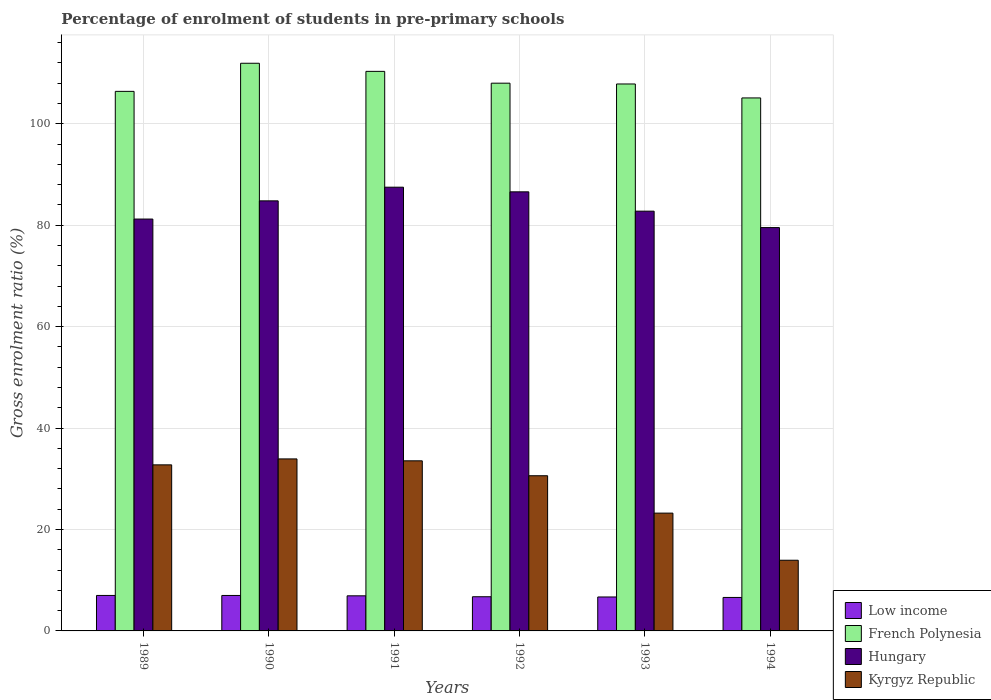How many different coloured bars are there?
Ensure brevity in your answer.  4. Are the number of bars per tick equal to the number of legend labels?
Keep it short and to the point. Yes. How many bars are there on the 6th tick from the right?
Offer a terse response. 4. In how many cases, is the number of bars for a given year not equal to the number of legend labels?
Your answer should be compact. 0. What is the percentage of students enrolled in pre-primary schools in Low income in 1994?
Provide a succinct answer. 6.6. Across all years, what is the maximum percentage of students enrolled in pre-primary schools in Low income?
Your response must be concise. 6.99. Across all years, what is the minimum percentage of students enrolled in pre-primary schools in Hungary?
Give a very brief answer. 79.53. What is the total percentage of students enrolled in pre-primary schools in French Polynesia in the graph?
Your response must be concise. 649.58. What is the difference between the percentage of students enrolled in pre-primary schools in Kyrgyz Republic in 1992 and that in 1994?
Provide a short and direct response. 16.66. What is the difference between the percentage of students enrolled in pre-primary schools in Low income in 1993 and the percentage of students enrolled in pre-primary schools in French Polynesia in 1990?
Your response must be concise. -105.23. What is the average percentage of students enrolled in pre-primary schools in Hungary per year?
Ensure brevity in your answer.  83.73. In the year 1994, what is the difference between the percentage of students enrolled in pre-primary schools in French Polynesia and percentage of students enrolled in pre-primary schools in Kyrgyz Republic?
Provide a short and direct response. 91.16. What is the ratio of the percentage of students enrolled in pre-primary schools in Hungary in 1989 to that in 1993?
Your answer should be compact. 0.98. Is the percentage of students enrolled in pre-primary schools in French Polynesia in 1989 less than that in 1990?
Provide a succinct answer. Yes. What is the difference between the highest and the second highest percentage of students enrolled in pre-primary schools in Kyrgyz Republic?
Give a very brief answer. 0.38. What is the difference between the highest and the lowest percentage of students enrolled in pre-primary schools in Kyrgyz Republic?
Offer a very short reply. 19.98. In how many years, is the percentage of students enrolled in pre-primary schools in Low income greater than the average percentage of students enrolled in pre-primary schools in Low income taken over all years?
Provide a succinct answer. 3. What does the 2nd bar from the left in 1990 represents?
Your response must be concise. French Polynesia. What does the 2nd bar from the right in 1993 represents?
Ensure brevity in your answer.  Hungary. Is it the case that in every year, the sum of the percentage of students enrolled in pre-primary schools in French Polynesia and percentage of students enrolled in pre-primary schools in Hungary is greater than the percentage of students enrolled in pre-primary schools in Low income?
Make the answer very short. Yes. How many years are there in the graph?
Offer a terse response. 6. Does the graph contain grids?
Your answer should be very brief. Yes. How are the legend labels stacked?
Your answer should be compact. Vertical. What is the title of the graph?
Give a very brief answer. Percentage of enrolment of students in pre-primary schools. Does "Micronesia" appear as one of the legend labels in the graph?
Offer a terse response. No. What is the Gross enrolment ratio (%) in Low income in 1989?
Give a very brief answer. 6.99. What is the Gross enrolment ratio (%) of French Polynesia in 1989?
Ensure brevity in your answer.  106.39. What is the Gross enrolment ratio (%) in Hungary in 1989?
Keep it short and to the point. 81.21. What is the Gross enrolment ratio (%) in Kyrgyz Republic in 1989?
Offer a terse response. 32.74. What is the Gross enrolment ratio (%) in Low income in 1990?
Provide a short and direct response. 6.99. What is the Gross enrolment ratio (%) in French Polynesia in 1990?
Provide a succinct answer. 111.93. What is the Gross enrolment ratio (%) of Hungary in 1990?
Provide a succinct answer. 84.8. What is the Gross enrolment ratio (%) in Kyrgyz Republic in 1990?
Offer a very short reply. 33.92. What is the Gross enrolment ratio (%) in Low income in 1991?
Ensure brevity in your answer.  6.92. What is the Gross enrolment ratio (%) in French Polynesia in 1991?
Offer a terse response. 110.33. What is the Gross enrolment ratio (%) in Hungary in 1991?
Your answer should be very brief. 87.49. What is the Gross enrolment ratio (%) in Kyrgyz Republic in 1991?
Make the answer very short. 33.54. What is the Gross enrolment ratio (%) of Low income in 1992?
Ensure brevity in your answer.  6.74. What is the Gross enrolment ratio (%) of French Polynesia in 1992?
Offer a terse response. 108. What is the Gross enrolment ratio (%) of Hungary in 1992?
Ensure brevity in your answer.  86.58. What is the Gross enrolment ratio (%) of Kyrgyz Republic in 1992?
Give a very brief answer. 30.6. What is the Gross enrolment ratio (%) in Low income in 1993?
Your answer should be very brief. 6.69. What is the Gross enrolment ratio (%) in French Polynesia in 1993?
Ensure brevity in your answer.  107.84. What is the Gross enrolment ratio (%) in Hungary in 1993?
Keep it short and to the point. 82.77. What is the Gross enrolment ratio (%) of Kyrgyz Republic in 1993?
Give a very brief answer. 23.23. What is the Gross enrolment ratio (%) of Low income in 1994?
Your response must be concise. 6.6. What is the Gross enrolment ratio (%) of French Polynesia in 1994?
Your answer should be compact. 105.09. What is the Gross enrolment ratio (%) in Hungary in 1994?
Provide a succinct answer. 79.53. What is the Gross enrolment ratio (%) in Kyrgyz Republic in 1994?
Ensure brevity in your answer.  13.94. Across all years, what is the maximum Gross enrolment ratio (%) in Low income?
Give a very brief answer. 6.99. Across all years, what is the maximum Gross enrolment ratio (%) of French Polynesia?
Your answer should be compact. 111.93. Across all years, what is the maximum Gross enrolment ratio (%) of Hungary?
Offer a very short reply. 87.49. Across all years, what is the maximum Gross enrolment ratio (%) of Kyrgyz Republic?
Ensure brevity in your answer.  33.92. Across all years, what is the minimum Gross enrolment ratio (%) in Low income?
Keep it short and to the point. 6.6. Across all years, what is the minimum Gross enrolment ratio (%) in French Polynesia?
Provide a short and direct response. 105.09. Across all years, what is the minimum Gross enrolment ratio (%) of Hungary?
Your answer should be compact. 79.53. Across all years, what is the minimum Gross enrolment ratio (%) of Kyrgyz Republic?
Keep it short and to the point. 13.94. What is the total Gross enrolment ratio (%) of Low income in the graph?
Your answer should be very brief. 40.94. What is the total Gross enrolment ratio (%) of French Polynesia in the graph?
Offer a terse response. 649.58. What is the total Gross enrolment ratio (%) of Hungary in the graph?
Keep it short and to the point. 502.37. What is the total Gross enrolment ratio (%) of Kyrgyz Republic in the graph?
Ensure brevity in your answer.  167.96. What is the difference between the Gross enrolment ratio (%) in Low income in 1989 and that in 1990?
Provide a succinct answer. 0. What is the difference between the Gross enrolment ratio (%) in French Polynesia in 1989 and that in 1990?
Your answer should be very brief. -5.54. What is the difference between the Gross enrolment ratio (%) of Hungary in 1989 and that in 1990?
Give a very brief answer. -3.59. What is the difference between the Gross enrolment ratio (%) in Kyrgyz Republic in 1989 and that in 1990?
Give a very brief answer. -1.17. What is the difference between the Gross enrolment ratio (%) in Low income in 1989 and that in 1991?
Offer a terse response. 0.07. What is the difference between the Gross enrolment ratio (%) in French Polynesia in 1989 and that in 1991?
Make the answer very short. -3.94. What is the difference between the Gross enrolment ratio (%) in Hungary in 1989 and that in 1991?
Give a very brief answer. -6.28. What is the difference between the Gross enrolment ratio (%) of Kyrgyz Republic in 1989 and that in 1991?
Your answer should be compact. -0.8. What is the difference between the Gross enrolment ratio (%) of Low income in 1989 and that in 1992?
Keep it short and to the point. 0.26. What is the difference between the Gross enrolment ratio (%) in French Polynesia in 1989 and that in 1992?
Ensure brevity in your answer.  -1.61. What is the difference between the Gross enrolment ratio (%) of Hungary in 1989 and that in 1992?
Offer a very short reply. -5.37. What is the difference between the Gross enrolment ratio (%) in Kyrgyz Republic in 1989 and that in 1992?
Provide a short and direct response. 2.15. What is the difference between the Gross enrolment ratio (%) in Low income in 1989 and that in 1993?
Give a very brief answer. 0.3. What is the difference between the Gross enrolment ratio (%) of French Polynesia in 1989 and that in 1993?
Provide a short and direct response. -1.46. What is the difference between the Gross enrolment ratio (%) of Hungary in 1989 and that in 1993?
Provide a succinct answer. -1.56. What is the difference between the Gross enrolment ratio (%) in Kyrgyz Republic in 1989 and that in 1993?
Your response must be concise. 9.52. What is the difference between the Gross enrolment ratio (%) of Low income in 1989 and that in 1994?
Ensure brevity in your answer.  0.4. What is the difference between the Gross enrolment ratio (%) in French Polynesia in 1989 and that in 1994?
Make the answer very short. 1.3. What is the difference between the Gross enrolment ratio (%) of Hungary in 1989 and that in 1994?
Provide a succinct answer. 1.68. What is the difference between the Gross enrolment ratio (%) of Kyrgyz Republic in 1989 and that in 1994?
Provide a short and direct response. 18.81. What is the difference between the Gross enrolment ratio (%) of Low income in 1990 and that in 1991?
Make the answer very short. 0.07. What is the difference between the Gross enrolment ratio (%) in French Polynesia in 1990 and that in 1991?
Your answer should be compact. 1.6. What is the difference between the Gross enrolment ratio (%) in Hungary in 1990 and that in 1991?
Ensure brevity in your answer.  -2.7. What is the difference between the Gross enrolment ratio (%) in Kyrgyz Republic in 1990 and that in 1991?
Offer a terse response. 0.38. What is the difference between the Gross enrolment ratio (%) of Low income in 1990 and that in 1992?
Give a very brief answer. 0.25. What is the difference between the Gross enrolment ratio (%) of French Polynesia in 1990 and that in 1992?
Provide a short and direct response. 3.93. What is the difference between the Gross enrolment ratio (%) in Hungary in 1990 and that in 1992?
Your response must be concise. -1.78. What is the difference between the Gross enrolment ratio (%) of Kyrgyz Republic in 1990 and that in 1992?
Provide a short and direct response. 3.32. What is the difference between the Gross enrolment ratio (%) of Low income in 1990 and that in 1993?
Keep it short and to the point. 0.3. What is the difference between the Gross enrolment ratio (%) in French Polynesia in 1990 and that in 1993?
Provide a short and direct response. 4.09. What is the difference between the Gross enrolment ratio (%) in Hungary in 1990 and that in 1993?
Keep it short and to the point. 2.03. What is the difference between the Gross enrolment ratio (%) of Kyrgyz Republic in 1990 and that in 1993?
Make the answer very short. 10.69. What is the difference between the Gross enrolment ratio (%) of Low income in 1990 and that in 1994?
Give a very brief answer. 0.39. What is the difference between the Gross enrolment ratio (%) of French Polynesia in 1990 and that in 1994?
Offer a terse response. 6.84. What is the difference between the Gross enrolment ratio (%) of Hungary in 1990 and that in 1994?
Your answer should be compact. 5.27. What is the difference between the Gross enrolment ratio (%) in Kyrgyz Republic in 1990 and that in 1994?
Your answer should be very brief. 19.98. What is the difference between the Gross enrolment ratio (%) in Low income in 1991 and that in 1992?
Ensure brevity in your answer.  0.18. What is the difference between the Gross enrolment ratio (%) of French Polynesia in 1991 and that in 1992?
Your answer should be very brief. 2.33. What is the difference between the Gross enrolment ratio (%) in Hungary in 1991 and that in 1992?
Make the answer very short. 0.92. What is the difference between the Gross enrolment ratio (%) of Kyrgyz Republic in 1991 and that in 1992?
Offer a very short reply. 2.94. What is the difference between the Gross enrolment ratio (%) of Low income in 1991 and that in 1993?
Provide a short and direct response. 0.23. What is the difference between the Gross enrolment ratio (%) of French Polynesia in 1991 and that in 1993?
Offer a very short reply. 2.49. What is the difference between the Gross enrolment ratio (%) in Hungary in 1991 and that in 1993?
Your answer should be compact. 4.73. What is the difference between the Gross enrolment ratio (%) of Kyrgyz Republic in 1991 and that in 1993?
Your response must be concise. 10.31. What is the difference between the Gross enrolment ratio (%) of Low income in 1991 and that in 1994?
Offer a very short reply. 0.32. What is the difference between the Gross enrolment ratio (%) in French Polynesia in 1991 and that in 1994?
Your answer should be very brief. 5.24. What is the difference between the Gross enrolment ratio (%) in Hungary in 1991 and that in 1994?
Your response must be concise. 7.96. What is the difference between the Gross enrolment ratio (%) of Kyrgyz Republic in 1991 and that in 1994?
Offer a very short reply. 19.6. What is the difference between the Gross enrolment ratio (%) in Low income in 1992 and that in 1993?
Provide a short and direct response. 0.04. What is the difference between the Gross enrolment ratio (%) of French Polynesia in 1992 and that in 1993?
Offer a terse response. 0.16. What is the difference between the Gross enrolment ratio (%) of Hungary in 1992 and that in 1993?
Your response must be concise. 3.81. What is the difference between the Gross enrolment ratio (%) of Kyrgyz Republic in 1992 and that in 1993?
Offer a terse response. 7.37. What is the difference between the Gross enrolment ratio (%) of Low income in 1992 and that in 1994?
Offer a terse response. 0.14. What is the difference between the Gross enrolment ratio (%) in French Polynesia in 1992 and that in 1994?
Make the answer very short. 2.91. What is the difference between the Gross enrolment ratio (%) in Hungary in 1992 and that in 1994?
Make the answer very short. 7.05. What is the difference between the Gross enrolment ratio (%) of Kyrgyz Republic in 1992 and that in 1994?
Your answer should be compact. 16.66. What is the difference between the Gross enrolment ratio (%) in Low income in 1993 and that in 1994?
Your answer should be very brief. 0.1. What is the difference between the Gross enrolment ratio (%) in French Polynesia in 1993 and that in 1994?
Give a very brief answer. 2.75. What is the difference between the Gross enrolment ratio (%) of Hungary in 1993 and that in 1994?
Offer a terse response. 3.24. What is the difference between the Gross enrolment ratio (%) of Kyrgyz Republic in 1993 and that in 1994?
Provide a short and direct response. 9.29. What is the difference between the Gross enrolment ratio (%) in Low income in 1989 and the Gross enrolment ratio (%) in French Polynesia in 1990?
Your response must be concise. -104.93. What is the difference between the Gross enrolment ratio (%) of Low income in 1989 and the Gross enrolment ratio (%) of Hungary in 1990?
Ensure brevity in your answer.  -77.8. What is the difference between the Gross enrolment ratio (%) in Low income in 1989 and the Gross enrolment ratio (%) in Kyrgyz Republic in 1990?
Your response must be concise. -26.92. What is the difference between the Gross enrolment ratio (%) of French Polynesia in 1989 and the Gross enrolment ratio (%) of Hungary in 1990?
Offer a terse response. 21.59. What is the difference between the Gross enrolment ratio (%) in French Polynesia in 1989 and the Gross enrolment ratio (%) in Kyrgyz Republic in 1990?
Ensure brevity in your answer.  72.47. What is the difference between the Gross enrolment ratio (%) in Hungary in 1989 and the Gross enrolment ratio (%) in Kyrgyz Republic in 1990?
Your answer should be compact. 47.29. What is the difference between the Gross enrolment ratio (%) in Low income in 1989 and the Gross enrolment ratio (%) in French Polynesia in 1991?
Keep it short and to the point. -103.34. What is the difference between the Gross enrolment ratio (%) in Low income in 1989 and the Gross enrolment ratio (%) in Hungary in 1991?
Provide a succinct answer. -80.5. What is the difference between the Gross enrolment ratio (%) of Low income in 1989 and the Gross enrolment ratio (%) of Kyrgyz Republic in 1991?
Your response must be concise. -26.55. What is the difference between the Gross enrolment ratio (%) in French Polynesia in 1989 and the Gross enrolment ratio (%) in Hungary in 1991?
Keep it short and to the point. 18.89. What is the difference between the Gross enrolment ratio (%) in French Polynesia in 1989 and the Gross enrolment ratio (%) in Kyrgyz Republic in 1991?
Your answer should be very brief. 72.85. What is the difference between the Gross enrolment ratio (%) of Hungary in 1989 and the Gross enrolment ratio (%) of Kyrgyz Republic in 1991?
Keep it short and to the point. 47.67. What is the difference between the Gross enrolment ratio (%) in Low income in 1989 and the Gross enrolment ratio (%) in French Polynesia in 1992?
Your answer should be very brief. -101.01. What is the difference between the Gross enrolment ratio (%) in Low income in 1989 and the Gross enrolment ratio (%) in Hungary in 1992?
Give a very brief answer. -79.58. What is the difference between the Gross enrolment ratio (%) in Low income in 1989 and the Gross enrolment ratio (%) in Kyrgyz Republic in 1992?
Your response must be concise. -23.6. What is the difference between the Gross enrolment ratio (%) of French Polynesia in 1989 and the Gross enrolment ratio (%) of Hungary in 1992?
Give a very brief answer. 19.81. What is the difference between the Gross enrolment ratio (%) in French Polynesia in 1989 and the Gross enrolment ratio (%) in Kyrgyz Republic in 1992?
Your answer should be very brief. 75.79. What is the difference between the Gross enrolment ratio (%) of Hungary in 1989 and the Gross enrolment ratio (%) of Kyrgyz Republic in 1992?
Ensure brevity in your answer.  50.61. What is the difference between the Gross enrolment ratio (%) of Low income in 1989 and the Gross enrolment ratio (%) of French Polynesia in 1993?
Give a very brief answer. -100.85. What is the difference between the Gross enrolment ratio (%) of Low income in 1989 and the Gross enrolment ratio (%) of Hungary in 1993?
Give a very brief answer. -75.77. What is the difference between the Gross enrolment ratio (%) in Low income in 1989 and the Gross enrolment ratio (%) in Kyrgyz Republic in 1993?
Your response must be concise. -16.23. What is the difference between the Gross enrolment ratio (%) in French Polynesia in 1989 and the Gross enrolment ratio (%) in Hungary in 1993?
Make the answer very short. 23.62. What is the difference between the Gross enrolment ratio (%) of French Polynesia in 1989 and the Gross enrolment ratio (%) of Kyrgyz Republic in 1993?
Your response must be concise. 83.16. What is the difference between the Gross enrolment ratio (%) of Hungary in 1989 and the Gross enrolment ratio (%) of Kyrgyz Republic in 1993?
Your answer should be compact. 57.98. What is the difference between the Gross enrolment ratio (%) of Low income in 1989 and the Gross enrolment ratio (%) of French Polynesia in 1994?
Your answer should be compact. -98.1. What is the difference between the Gross enrolment ratio (%) of Low income in 1989 and the Gross enrolment ratio (%) of Hungary in 1994?
Your response must be concise. -72.53. What is the difference between the Gross enrolment ratio (%) of Low income in 1989 and the Gross enrolment ratio (%) of Kyrgyz Republic in 1994?
Your response must be concise. -6.94. What is the difference between the Gross enrolment ratio (%) in French Polynesia in 1989 and the Gross enrolment ratio (%) in Hungary in 1994?
Give a very brief answer. 26.86. What is the difference between the Gross enrolment ratio (%) of French Polynesia in 1989 and the Gross enrolment ratio (%) of Kyrgyz Republic in 1994?
Offer a very short reply. 92.45. What is the difference between the Gross enrolment ratio (%) in Hungary in 1989 and the Gross enrolment ratio (%) in Kyrgyz Republic in 1994?
Keep it short and to the point. 67.27. What is the difference between the Gross enrolment ratio (%) of Low income in 1990 and the Gross enrolment ratio (%) of French Polynesia in 1991?
Your answer should be very brief. -103.34. What is the difference between the Gross enrolment ratio (%) of Low income in 1990 and the Gross enrolment ratio (%) of Hungary in 1991?
Provide a succinct answer. -80.5. What is the difference between the Gross enrolment ratio (%) of Low income in 1990 and the Gross enrolment ratio (%) of Kyrgyz Republic in 1991?
Keep it short and to the point. -26.55. What is the difference between the Gross enrolment ratio (%) of French Polynesia in 1990 and the Gross enrolment ratio (%) of Hungary in 1991?
Make the answer very short. 24.44. What is the difference between the Gross enrolment ratio (%) of French Polynesia in 1990 and the Gross enrolment ratio (%) of Kyrgyz Republic in 1991?
Provide a short and direct response. 78.39. What is the difference between the Gross enrolment ratio (%) in Hungary in 1990 and the Gross enrolment ratio (%) in Kyrgyz Republic in 1991?
Ensure brevity in your answer.  51.26. What is the difference between the Gross enrolment ratio (%) in Low income in 1990 and the Gross enrolment ratio (%) in French Polynesia in 1992?
Ensure brevity in your answer.  -101.01. What is the difference between the Gross enrolment ratio (%) in Low income in 1990 and the Gross enrolment ratio (%) in Hungary in 1992?
Make the answer very short. -79.59. What is the difference between the Gross enrolment ratio (%) of Low income in 1990 and the Gross enrolment ratio (%) of Kyrgyz Republic in 1992?
Your answer should be compact. -23.61. What is the difference between the Gross enrolment ratio (%) of French Polynesia in 1990 and the Gross enrolment ratio (%) of Hungary in 1992?
Provide a short and direct response. 25.35. What is the difference between the Gross enrolment ratio (%) in French Polynesia in 1990 and the Gross enrolment ratio (%) in Kyrgyz Republic in 1992?
Keep it short and to the point. 81.33. What is the difference between the Gross enrolment ratio (%) in Hungary in 1990 and the Gross enrolment ratio (%) in Kyrgyz Republic in 1992?
Ensure brevity in your answer.  54.2. What is the difference between the Gross enrolment ratio (%) in Low income in 1990 and the Gross enrolment ratio (%) in French Polynesia in 1993?
Keep it short and to the point. -100.85. What is the difference between the Gross enrolment ratio (%) of Low income in 1990 and the Gross enrolment ratio (%) of Hungary in 1993?
Offer a very short reply. -75.78. What is the difference between the Gross enrolment ratio (%) in Low income in 1990 and the Gross enrolment ratio (%) in Kyrgyz Republic in 1993?
Your answer should be compact. -16.24. What is the difference between the Gross enrolment ratio (%) of French Polynesia in 1990 and the Gross enrolment ratio (%) of Hungary in 1993?
Make the answer very short. 29.16. What is the difference between the Gross enrolment ratio (%) of French Polynesia in 1990 and the Gross enrolment ratio (%) of Kyrgyz Republic in 1993?
Provide a short and direct response. 88.7. What is the difference between the Gross enrolment ratio (%) in Hungary in 1990 and the Gross enrolment ratio (%) in Kyrgyz Republic in 1993?
Keep it short and to the point. 61.57. What is the difference between the Gross enrolment ratio (%) of Low income in 1990 and the Gross enrolment ratio (%) of French Polynesia in 1994?
Provide a succinct answer. -98.1. What is the difference between the Gross enrolment ratio (%) of Low income in 1990 and the Gross enrolment ratio (%) of Hungary in 1994?
Offer a terse response. -72.54. What is the difference between the Gross enrolment ratio (%) in Low income in 1990 and the Gross enrolment ratio (%) in Kyrgyz Republic in 1994?
Provide a short and direct response. -6.94. What is the difference between the Gross enrolment ratio (%) of French Polynesia in 1990 and the Gross enrolment ratio (%) of Hungary in 1994?
Give a very brief answer. 32.4. What is the difference between the Gross enrolment ratio (%) in French Polynesia in 1990 and the Gross enrolment ratio (%) in Kyrgyz Republic in 1994?
Give a very brief answer. 97.99. What is the difference between the Gross enrolment ratio (%) in Hungary in 1990 and the Gross enrolment ratio (%) in Kyrgyz Republic in 1994?
Ensure brevity in your answer.  70.86. What is the difference between the Gross enrolment ratio (%) in Low income in 1991 and the Gross enrolment ratio (%) in French Polynesia in 1992?
Provide a succinct answer. -101.08. What is the difference between the Gross enrolment ratio (%) of Low income in 1991 and the Gross enrolment ratio (%) of Hungary in 1992?
Offer a terse response. -79.66. What is the difference between the Gross enrolment ratio (%) of Low income in 1991 and the Gross enrolment ratio (%) of Kyrgyz Republic in 1992?
Provide a succinct answer. -23.68. What is the difference between the Gross enrolment ratio (%) of French Polynesia in 1991 and the Gross enrolment ratio (%) of Hungary in 1992?
Offer a very short reply. 23.75. What is the difference between the Gross enrolment ratio (%) of French Polynesia in 1991 and the Gross enrolment ratio (%) of Kyrgyz Republic in 1992?
Make the answer very short. 79.73. What is the difference between the Gross enrolment ratio (%) of Hungary in 1991 and the Gross enrolment ratio (%) of Kyrgyz Republic in 1992?
Ensure brevity in your answer.  56.89. What is the difference between the Gross enrolment ratio (%) of Low income in 1991 and the Gross enrolment ratio (%) of French Polynesia in 1993?
Your response must be concise. -100.92. What is the difference between the Gross enrolment ratio (%) of Low income in 1991 and the Gross enrolment ratio (%) of Hungary in 1993?
Offer a terse response. -75.85. What is the difference between the Gross enrolment ratio (%) in Low income in 1991 and the Gross enrolment ratio (%) in Kyrgyz Republic in 1993?
Keep it short and to the point. -16.31. What is the difference between the Gross enrolment ratio (%) in French Polynesia in 1991 and the Gross enrolment ratio (%) in Hungary in 1993?
Ensure brevity in your answer.  27.56. What is the difference between the Gross enrolment ratio (%) of French Polynesia in 1991 and the Gross enrolment ratio (%) of Kyrgyz Republic in 1993?
Give a very brief answer. 87.1. What is the difference between the Gross enrolment ratio (%) of Hungary in 1991 and the Gross enrolment ratio (%) of Kyrgyz Republic in 1993?
Offer a very short reply. 64.27. What is the difference between the Gross enrolment ratio (%) in Low income in 1991 and the Gross enrolment ratio (%) in French Polynesia in 1994?
Your answer should be compact. -98.17. What is the difference between the Gross enrolment ratio (%) in Low income in 1991 and the Gross enrolment ratio (%) in Hungary in 1994?
Offer a terse response. -72.61. What is the difference between the Gross enrolment ratio (%) in Low income in 1991 and the Gross enrolment ratio (%) in Kyrgyz Republic in 1994?
Provide a short and direct response. -7.01. What is the difference between the Gross enrolment ratio (%) in French Polynesia in 1991 and the Gross enrolment ratio (%) in Hungary in 1994?
Provide a succinct answer. 30.8. What is the difference between the Gross enrolment ratio (%) in French Polynesia in 1991 and the Gross enrolment ratio (%) in Kyrgyz Republic in 1994?
Your response must be concise. 96.39. What is the difference between the Gross enrolment ratio (%) of Hungary in 1991 and the Gross enrolment ratio (%) of Kyrgyz Republic in 1994?
Offer a terse response. 73.56. What is the difference between the Gross enrolment ratio (%) of Low income in 1992 and the Gross enrolment ratio (%) of French Polynesia in 1993?
Provide a succinct answer. -101.1. What is the difference between the Gross enrolment ratio (%) of Low income in 1992 and the Gross enrolment ratio (%) of Hungary in 1993?
Offer a very short reply. -76.03. What is the difference between the Gross enrolment ratio (%) of Low income in 1992 and the Gross enrolment ratio (%) of Kyrgyz Republic in 1993?
Keep it short and to the point. -16.49. What is the difference between the Gross enrolment ratio (%) in French Polynesia in 1992 and the Gross enrolment ratio (%) in Hungary in 1993?
Offer a terse response. 25.23. What is the difference between the Gross enrolment ratio (%) in French Polynesia in 1992 and the Gross enrolment ratio (%) in Kyrgyz Republic in 1993?
Your response must be concise. 84.77. What is the difference between the Gross enrolment ratio (%) of Hungary in 1992 and the Gross enrolment ratio (%) of Kyrgyz Republic in 1993?
Keep it short and to the point. 63.35. What is the difference between the Gross enrolment ratio (%) in Low income in 1992 and the Gross enrolment ratio (%) in French Polynesia in 1994?
Offer a terse response. -98.35. What is the difference between the Gross enrolment ratio (%) of Low income in 1992 and the Gross enrolment ratio (%) of Hungary in 1994?
Give a very brief answer. -72.79. What is the difference between the Gross enrolment ratio (%) of Low income in 1992 and the Gross enrolment ratio (%) of Kyrgyz Republic in 1994?
Your response must be concise. -7.2. What is the difference between the Gross enrolment ratio (%) of French Polynesia in 1992 and the Gross enrolment ratio (%) of Hungary in 1994?
Offer a terse response. 28.47. What is the difference between the Gross enrolment ratio (%) of French Polynesia in 1992 and the Gross enrolment ratio (%) of Kyrgyz Republic in 1994?
Your response must be concise. 94.06. What is the difference between the Gross enrolment ratio (%) of Hungary in 1992 and the Gross enrolment ratio (%) of Kyrgyz Republic in 1994?
Offer a terse response. 72.64. What is the difference between the Gross enrolment ratio (%) of Low income in 1993 and the Gross enrolment ratio (%) of French Polynesia in 1994?
Offer a very short reply. -98.4. What is the difference between the Gross enrolment ratio (%) of Low income in 1993 and the Gross enrolment ratio (%) of Hungary in 1994?
Your answer should be compact. -72.83. What is the difference between the Gross enrolment ratio (%) of Low income in 1993 and the Gross enrolment ratio (%) of Kyrgyz Republic in 1994?
Offer a terse response. -7.24. What is the difference between the Gross enrolment ratio (%) in French Polynesia in 1993 and the Gross enrolment ratio (%) in Hungary in 1994?
Ensure brevity in your answer.  28.32. What is the difference between the Gross enrolment ratio (%) of French Polynesia in 1993 and the Gross enrolment ratio (%) of Kyrgyz Republic in 1994?
Your answer should be very brief. 93.91. What is the difference between the Gross enrolment ratio (%) of Hungary in 1993 and the Gross enrolment ratio (%) of Kyrgyz Republic in 1994?
Your answer should be very brief. 68.83. What is the average Gross enrolment ratio (%) of Low income per year?
Keep it short and to the point. 6.82. What is the average Gross enrolment ratio (%) of French Polynesia per year?
Your response must be concise. 108.26. What is the average Gross enrolment ratio (%) of Hungary per year?
Provide a succinct answer. 83.73. What is the average Gross enrolment ratio (%) of Kyrgyz Republic per year?
Keep it short and to the point. 27.99. In the year 1989, what is the difference between the Gross enrolment ratio (%) in Low income and Gross enrolment ratio (%) in French Polynesia?
Your response must be concise. -99.39. In the year 1989, what is the difference between the Gross enrolment ratio (%) in Low income and Gross enrolment ratio (%) in Hungary?
Your answer should be compact. -74.21. In the year 1989, what is the difference between the Gross enrolment ratio (%) in Low income and Gross enrolment ratio (%) in Kyrgyz Republic?
Keep it short and to the point. -25.75. In the year 1989, what is the difference between the Gross enrolment ratio (%) in French Polynesia and Gross enrolment ratio (%) in Hungary?
Keep it short and to the point. 25.18. In the year 1989, what is the difference between the Gross enrolment ratio (%) in French Polynesia and Gross enrolment ratio (%) in Kyrgyz Republic?
Keep it short and to the point. 73.64. In the year 1989, what is the difference between the Gross enrolment ratio (%) of Hungary and Gross enrolment ratio (%) of Kyrgyz Republic?
Ensure brevity in your answer.  48.46. In the year 1990, what is the difference between the Gross enrolment ratio (%) in Low income and Gross enrolment ratio (%) in French Polynesia?
Make the answer very short. -104.94. In the year 1990, what is the difference between the Gross enrolment ratio (%) in Low income and Gross enrolment ratio (%) in Hungary?
Your answer should be compact. -77.81. In the year 1990, what is the difference between the Gross enrolment ratio (%) of Low income and Gross enrolment ratio (%) of Kyrgyz Republic?
Your response must be concise. -26.93. In the year 1990, what is the difference between the Gross enrolment ratio (%) in French Polynesia and Gross enrolment ratio (%) in Hungary?
Provide a short and direct response. 27.13. In the year 1990, what is the difference between the Gross enrolment ratio (%) of French Polynesia and Gross enrolment ratio (%) of Kyrgyz Republic?
Ensure brevity in your answer.  78.01. In the year 1990, what is the difference between the Gross enrolment ratio (%) of Hungary and Gross enrolment ratio (%) of Kyrgyz Republic?
Your answer should be very brief. 50.88. In the year 1991, what is the difference between the Gross enrolment ratio (%) in Low income and Gross enrolment ratio (%) in French Polynesia?
Offer a terse response. -103.41. In the year 1991, what is the difference between the Gross enrolment ratio (%) in Low income and Gross enrolment ratio (%) in Hungary?
Your answer should be very brief. -80.57. In the year 1991, what is the difference between the Gross enrolment ratio (%) in Low income and Gross enrolment ratio (%) in Kyrgyz Republic?
Your answer should be compact. -26.62. In the year 1991, what is the difference between the Gross enrolment ratio (%) in French Polynesia and Gross enrolment ratio (%) in Hungary?
Offer a terse response. 22.84. In the year 1991, what is the difference between the Gross enrolment ratio (%) in French Polynesia and Gross enrolment ratio (%) in Kyrgyz Republic?
Ensure brevity in your answer.  76.79. In the year 1991, what is the difference between the Gross enrolment ratio (%) in Hungary and Gross enrolment ratio (%) in Kyrgyz Republic?
Offer a very short reply. 53.95. In the year 1992, what is the difference between the Gross enrolment ratio (%) in Low income and Gross enrolment ratio (%) in French Polynesia?
Your response must be concise. -101.26. In the year 1992, what is the difference between the Gross enrolment ratio (%) in Low income and Gross enrolment ratio (%) in Hungary?
Your response must be concise. -79.84. In the year 1992, what is the difference between the Gross enrolment ratio (%) in Low income and Gross enrolment ratio (%) in Kyrgyz Republic?
Make the answer very short. -23.86. In the year 1992, what is the difference between the Gross enrolment ratio (%) in French Polynesia and Gross enrolment ratio (%) in Hungary?
Your answer should be compact. 21.42. In the year 1992, what is the difference between the Gross enrolment ratio (%) of French Polynesia and Gross enrolment ratio (%) of Kyrgyz Republic?
Offer a very short reply. 77.4. In the year 1992, what is the difference between the Gross enrolment ratio (%) in Hungary and Gross enrolment ratio (%) in Kyrgyz Republic?
Your response must be concise. 55.98. In the year 1993, what is the difference between the Gross enrolment ratio (%) of Low income and Gross enrolment ratio (%) of French Polynesia?
Provide a succinct answer. -101.15. In the year 1993, what is the difference between the Gross enrolment ratio (%) in Low income and Gross enrolment ratio (%) in Hungary?
Your answer should be compact. -76.07. In the year 1993, what is the difference between the Gross enrolment ratio (%) of Low income and Gross enrolment ratio (%) of Kyrgyz Republic?
Your response must be concise. -16.53. In the year 1993, what is the difference between the Gross enrolment ratio (%) in French Polynesia and Gross enrolment ratio (%) in Hungary?
Offer a very short reply. 25.08. In the year 1993, what is the difference between the Gross enrolment ratio (%) in French Polynesia and Gross enrolment ratio (%) in Kyrgyz Republic?
Your answer should be compact. 84.62. In the year 1993, what is the difference between the Gross enrolment ratio (%) in Hungary and Gross enrolment ratio (%) in Kyrgyz Republic?
Make the answer very short. 59.54. In the year 1994, what is the difference between the Gross enrolment ratio (%) of Low income and Gross enrolment ratio (%) of French Polynesia?
Provide a short and direct response. -98.49. In the year 1994, what is the difference between the Gross enrolment ratio (%) in Low income and Gross enrolment ratio (%) in Hungary?
Provide a succinct answer. -72.93. In the year 1994, what is the difference between the Gross enrolment ratio (%) in Low income and Gross enrolment ratio (%) in Kyrgyz Republic?
Your answer should be very brief. -7.34. In the year 1994, what is the difference between the Gross enrolment ratio (%) in French Polynesia and Gross enrolment ratio (%) in Hungary?
Your answer should be very brief. 25.56. In the year 1994, what is the difference between the Gross enrolment ratio (%) of French Polynesia and Gross enrolment ratio (%) of Kyrgyz Republic?
Offer a terse response. 91.16. In the year 1994, what is the difference between the Gross enrolment ratio (%) in Hungary and Gross enrolment ratio (%) in Kyrgyz Republic?
Provide a succinct answer. 65.59. What is the ratio of the Gross enrolment ratio (%) of French Polynesia in 1989 to that in 1990?
Ensure brevity in your answer.  0.95. What is the ratio of the Gross enrolment ratio (%) of Hungary in 1989 to that in 1990?
Offer a terse response. 0.96. What is the ratio of the Gross enrolment ratio (%) of Kyrgyz Republic in 1989 to that in 1990?
Make the answer very short. 0.97. What is the ratio of the Gross enrolment ratio (%) of Low income in 1989 to that in 1991?
Keep it short and to the point. 1.01. What is the ratio of the Gross enrolment ratio (%) of French Polynesia in 1989 to that in 1991?
Give a very brief answer. 0.96. What is the ratio of the Gross enrolment ratio (%) of Hungary in 1989 to that in 1991?
Offer a terse response. 0.93. What is the ratio of the Gross enrolment ratio (%) of Kyrgyz Republic in 1989 to that in 1991?
Offer a terse response. 0.98. What is the ratio of the Gross enrolment ratio (%) of Low income in 1989 to that in 1992?
Ensure brevity in your answer.  1.04. What is the ratio of the Gross enrolment ratio (%) of French Polynesia in 1989 to that in 1992?
Keep it short and to the point. 0.99. What is the ratio of the Gross enrolment ratio (%) in Hungary in 1989 to that in 1992?
Your answer should be very brief. 0.94. What is the ratio of the Gross enrolment ratio (%) in Kyrgyz Republic in 1989 to that in 1992?
Give a very brief answer. 1.07. What is the ratio of the Gross enrolment ratio (%) of Low income in 1989 to that in 1993?
Provide a short and direct response. 1.04. What is the ratio of the Gross enrolment ratio (%) of French Polynesia in 1989 to that in 1993?
Make the answer very short. 0.99. What is the ratio of the Gross enrolment ratio (%) of Hungary in 1989 to that in 1993?
Ensure brevity in your answer.  0.98. What is the ratio of the Gross enrolment ratio (%) of Kyrgyz Republic in 1989 to that in 1993?
Offer a very short reply. 1.41. What is the ratio of the Gross enrolment ratio (%) of Low income in 1989 to that in 1994?
Provide a short and direct response. 1.06. What is the ratio of the Gross enrolment ratio (%) in French Polynesia in 1989 to that in 1994?
Keep it short and to the point. 1.01. What is the ratio of the Gross enrolment ratio (%) of Hungary in 1989 to that in 1994?
Keep it short and to the point. 1.02. What is the ratio of the Gross enrolment ratio (%) of Kyrgyz Republic in 1989 to that in 1994?
Your answer should be very brief. 2.35. What is the ratio of the Gross enrolment ratio (%) in Low income in 1990 to that in 1991?
Provide a succinct answer. 1.01. What is the ratio of the Gross enrolment ratio (%) in French Polynesia in 1990 to that in 1991?
Offer a very short reply. 1.01. What is the ratio of the Gross enrolment ratio (%) of Hungary in 1990 to that in 1991?
Keep it short and to the point. 0.97. What is the ratio of the Gross enrolment ratio (%) in Kyrgyz Republic in 1990 to that in 1991?
Provide a short and direct response. 1.01. What is the ratio of the Gross enrolment ratio (%) in Low income in 1990 to that in 1992?
Provide a short and direct response. 1.04. What is the ratio of the Gross enrolment ratio (%) in French Polynesia in 1990 to that in 1992?
Give a very brief answer. 1.04. What is the ratio of the Gross enrolment ratio (%) of Hungary in 1990 to that in 1992?
Make the answer very short. 0.98. What is the ratio of the Gross enrolment ratio (%) in Kyrgyz Republic in 1990 to that in 1992?
Offer a very short reply. 1.11. What is the ratio of the Gross enrolment ratio (%) of Low income in 1990 to that in 1993?
Provide a short and direct response. 1.04. What is the ratio of the Gross enrolment ratio (%) in French Polynesia in 1990 to that in 1993?
Offer a very short reply. 1.04. What is the ratio of the Gross enrolment ratio (%) in Hungary in 1990 to that in 1993?
Provide a short and direct response. 1.02. What is the ratio of the Gross enrolment ratio (%) of Kyrgyz Republic in 1990 to that in 1993?
Your response must be concise. 1.46. What is the ratio of the Gross enrolment ratio (%) in Low income in 1990 to that in 1994?
Your answer should be compact. 1.06. What is the ratio of the Gross enrolment ratio (%) of French Polynesia in 1990 to that in 1994?
Provide a short and direct response. 1.07. What is the ratio of the Gross enrolment ratio (%) of Hungary in 1990 to that in 1994?
Make the answer very short. 1.07. What is the ratio of the Gross enrolment ratio (%) in Kyrgyz Republic in 1990 to that in 1994?
Keep it short and to the point. 2.43. What is the ratio of the Gross enrolment ratio (%) in Low income in 1991 to that in 1992?
Ensure brevity in your answer.  1.03. What is the ratio of the Gross enrolment ratio (%) in French Polynesia in 1991 to that in 1992?
Your answer should be compact. 1.02. What is the ratio of the Gross enrolment ratio (%) of Hungary in 1991 to that in 1992?
Offer a very short reply. 1.01. What is the ratio of the Gross enrolment ratio (%) in Kyrgyz Republic in 1991 to that in 1992?
Make the answer very short. 1.1. What is the ratio of the Gross enrolment ratio (%) of Low income in 1991 to that in 1993?
Give a very brief answer. 1.03. What is the ratio of the Gross enrolment ratio (%) of French Polynesia in 1991 to that in 1993?
Ensure brevity in your answer.  1.02. What is the ratio of the Gross enrolment ratio (%) in Hungary in 1991 to that in 1993?
Provide a short and direct response. 1.06. What is the ratio of the Gross enrolment ratio (%) of Kyrgyz Republic in 1991 to that in 1993?
Give a very brief answer. 1.44. What is the ratio of the Gross enrolment ratio (%) in Low income in 1991 to that in 1994?
Offer a very short reply. 1.05. What is the ratio of the Gross enrolment ratio (%) in French Polynesia in 1991 to that in 1994?
Give a very brief answer. 1.05. What is the ratio of the Gross enrolment ratio (%) of Hungary in 1991 to that in 1994?
Make the answer very short. 1.1. What is the ratio of the Gross enrolment ratio (%) of Kyrgyz Republic in 1991 to that in 1994?
Your answer should be compact. 2.41. What is the ratio of the Gross enrolment ratio (%) of Low income in 1992 to that in 1993?
Your answer should be compact. 1.01. What is the ratio of the Gross enrolment ratio (%) in French Polynesia in 1992 to that in 1993?
Ensure brevity in your answer.  1. What is the ratio of the Gross enrolment ratio (%) of Hungary in 1992 to that in 1993?
Ensure brevity in your answer.  1.05. What is the ratio of the Gross enrolment ratio (%) in Kyrgyz Republic in 1992 to that in 1993?
Your answer should be very brief. 1.32. What is the ratio of the Gross enrolment ratio (%) of Low income in 1992 to that in 1994?
Make the answer very short. 1.02. What is the ratio of the Gross enrolment ratio (%) in French Polynesia in 1992 to that in 1994?
Provide a succinct answer. 1.03. What is the ratio of the Gross enrolment ratio (%) in Hungary in 1992 to that in 1994?
Ensure brevity in your answer.  1.09. What is the ratio of the Gross enrolment ratio (%) in Kyrgyz Republic in 1992 to that in 1994?
Give a very brief answer. 2.2. What is the ratio of the Gross enrolment ratio (%) in Low income in 1993 to that in 1994?
Your answer should be very brief. 1.01. What is the ratio of the Gross enrolment ratio (%) in French Polynesia in 1993 to that in 1994?
Give a very brief answer. 1.03. What is the ratio of the Gross enrolment ratio (%) of Hungary in 1993 to that in 1994?
Your answer should be compact. 1.04. What is the ratio of the Gross enrolment ratio (%) in Kyrgyz Republic in 1993 to that in 1994?
Offer a terse response. 1.67. What is the difference between the highest and the second highest Gross enrolment ratio (%) in Low income?
Keep it short and to the point. 0. What is the difference between the highest and the second highest Gross enrolment ratio (%) in French Polynesia?
Offer a very short reply. 1.6. What is the difference between the highest and the second highest Gross enrolment ratio (%) of Hungary?
Ensure brevity in your answer.  0.92. What is the difference between the highest and the second highest Gross enrolment ratio (%) in Kyrgyz Republic?
Your response must be concise. 0.38. What is the difference between the highest and the lowest Gross enrolment ratio (%) in Low income?
Your answer should be compact. 0.4. What is the difference between the highest and the lowest Gross enrolment ratio (%) in French Polynesia?
Provide a succinct answer. 6.84. What is the difference between the highest and the lowest Gross enrolment ratio (%) of Hungary?
Your response must be concise. 7.96. What is the difference between the highest and the lowest Gross enrolment ratio (%) in Kyrgyz Republic?
Offer a very short reply. 19.98. 